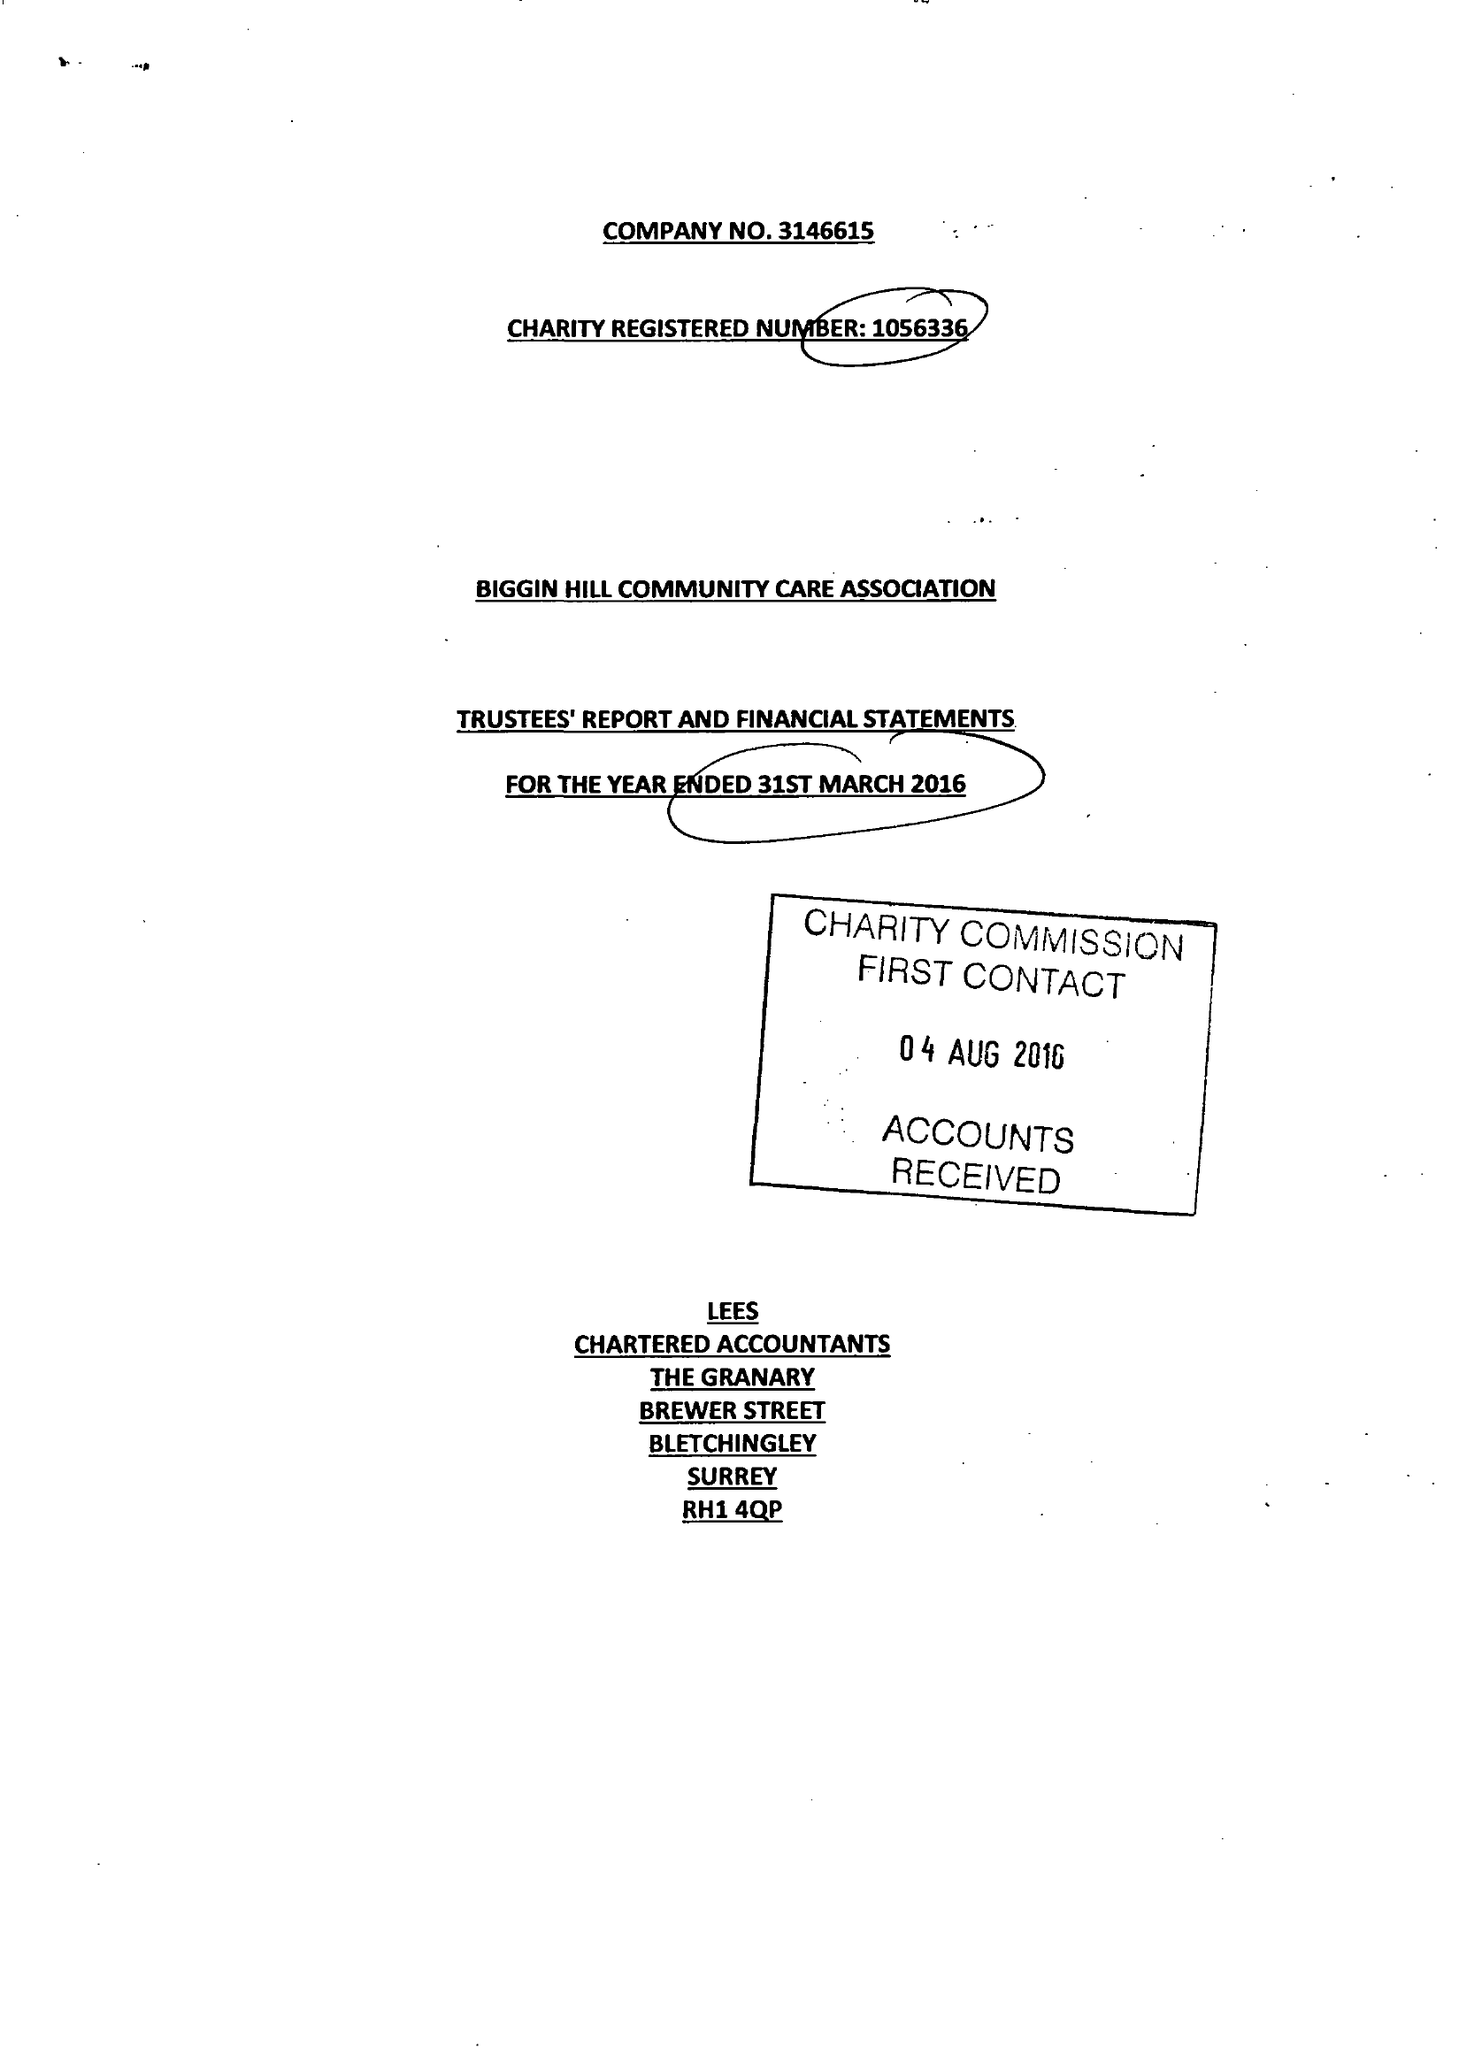What is the value for the charity_name?
Answer the question using a single word or phrase. Biggin Hill Community Care Association 